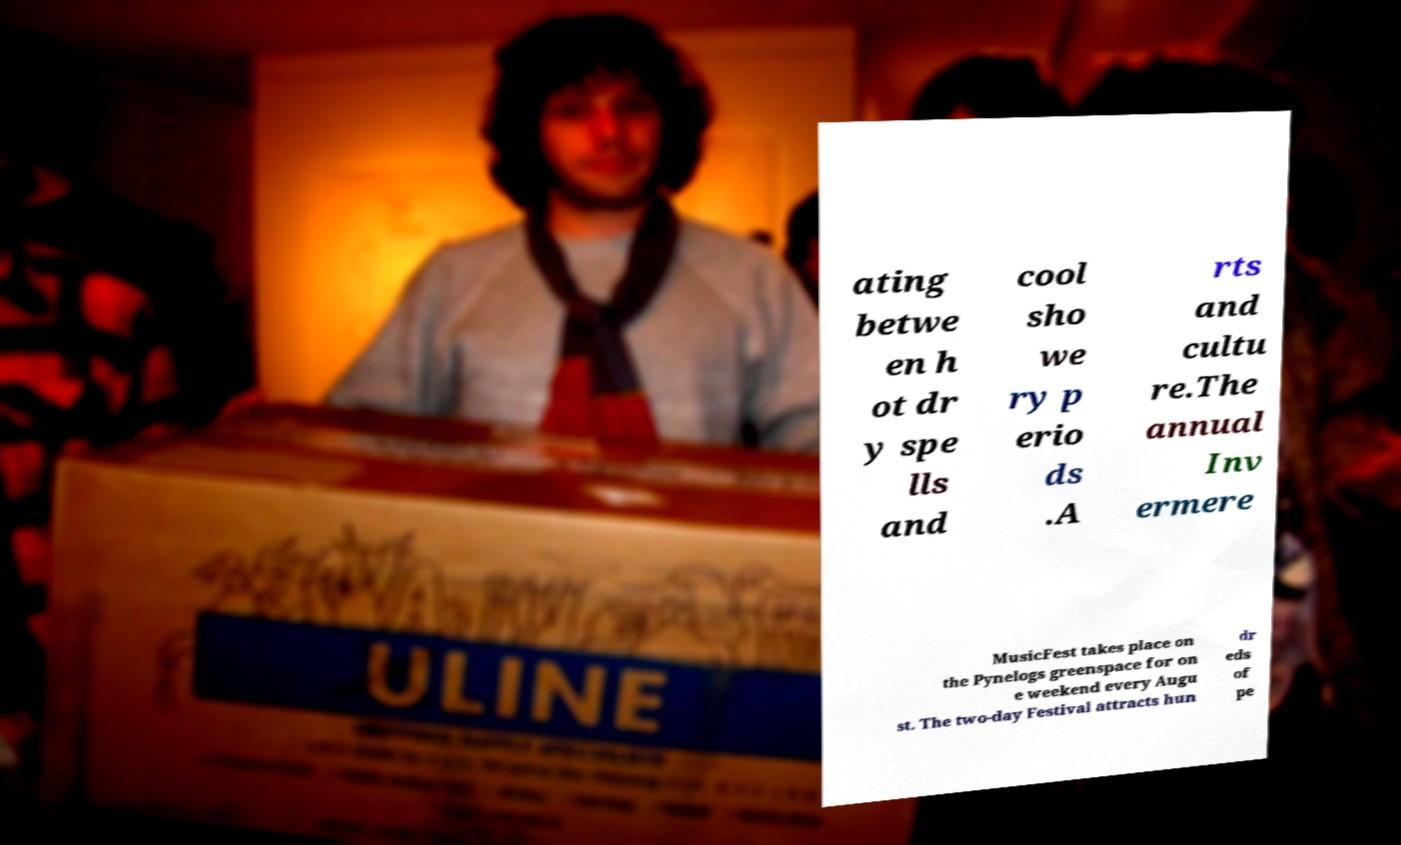Could you extract and type out the text from this image? ating betwe en h ot dr y spe lls and cool sho we ry p erio ds .A rts and cultu re.The annual Inv ermere MusicFest takes place on the Pynelogs greenspace for on e weekend every Augu st. The two-day Festival attracts hun dr eds of pe 